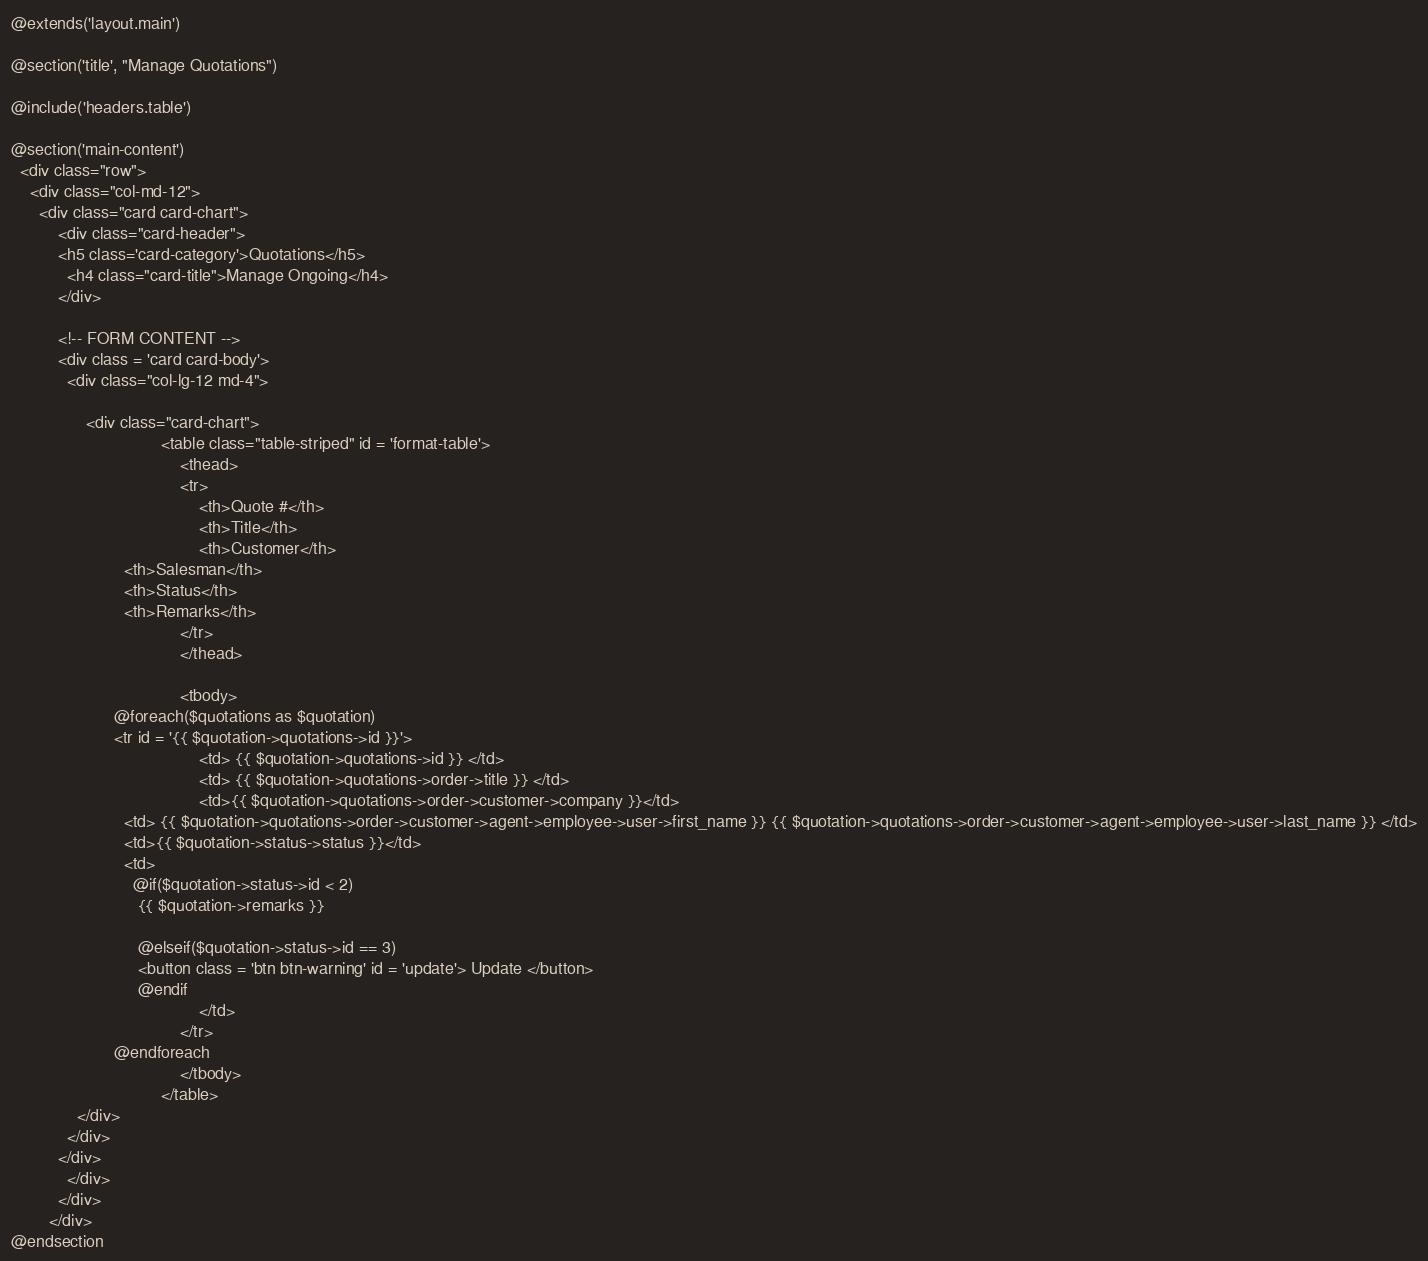Convert code to text. <code><loc_0><loc_0><loc_500><loc_500><_PHP_>@extends('layout.main')

@section('title', "Manage Quotations")

@include('headers.table')

@section('main-content')
  <div class="row">
    <div class="col-md-12">
      <div class="card card-chart">
          <div class="card-header">
          <h5 class='card-category'>Quotations</h5>
            <h4 class="card-title">Manage Ongoing</h4>
          </div>

          <!-- FORM CONTENT -->
          <div class = 'card card-body'>
            <div class="col-lg-12 md-4">

                <div class="card-chart">
  								<table class="table-striped" id = 'format-table'>
    								<thead>
      								<tr>
        								<th>Quote #</th>
        								<th>Title</th>
        								<th>Customer</th>
                        <th>Salesman</th>
                        <th>Status</th>
                        <th>Remarks</th>
      								</tr>
    								</thead>

    								<tbody>
                      @foreach($quotations as $quotation)
                      <tr id = '{{ $quotation->quotations->id }}'>
        								<td> {{ $quotation->quotations->id }} </td>
        								<td> {{ $quotation->quotations->order->title }} </td>
        								<td>{{ $quotation->quotations->order->customer->company }}</td>
                        <td> {{ $quotation->quotations->order->customer->agent->employee->user->first_name }} {{ $quotation->quotations->order->customer->agent->employee->user->last_name }} </td>
                        <td>{{ $quotation->status->status }}</td>
                        <td>
                          @if($quotation->status->id < 2)
                           {{ $quotation->remarks }}

                           @elseif($quotation->status->id == 3)
                           <button class = 'btn btn-warning' id = 'update'> Update </button>
                           @endif
        								</td>
      								</tr>
                      @endforeach
    								</tbody>
  								</table>
              </div>
            </div>
          </div>
            </div>
          </div>
        </div>
@endsection
</code> 